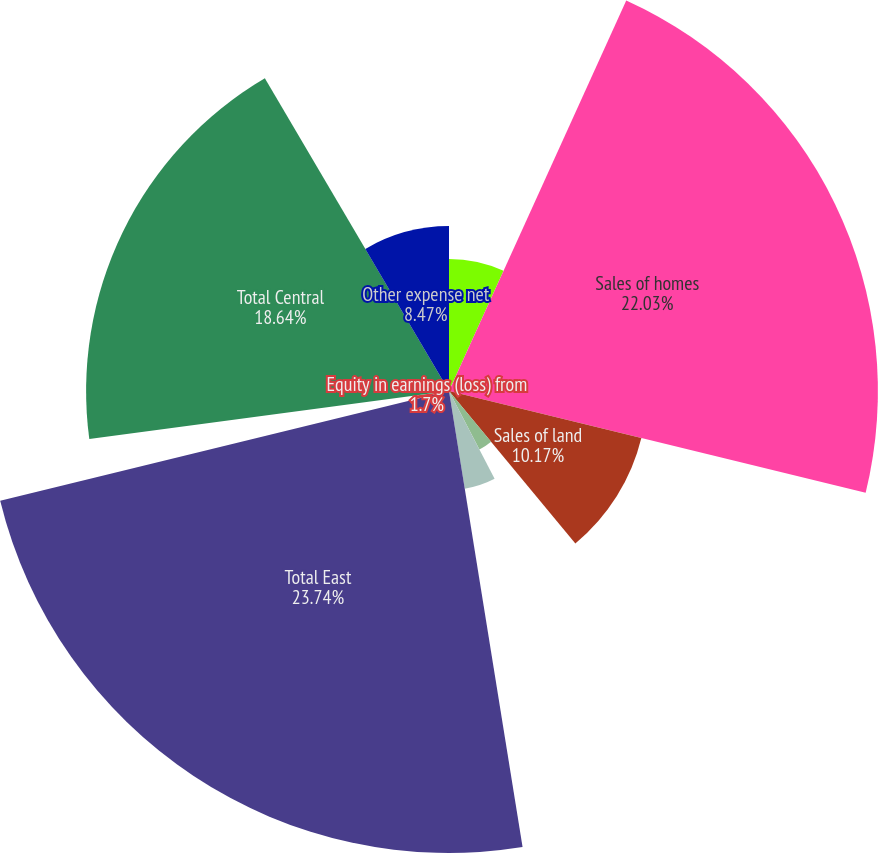Convert chart. <chart><loc_0><loc_0><loc_500><loc_500><pie_chart><fcel>(In thousands)<fcel>Sales of homes<fcel>Sales of land<fcel>Equity in loss from<fcel>Other income net<fcel>Total East<fcel>Equity in earnings (loss) from<fcel>Total Central<fcel>Equity in earnings from<fcel>Other expense net<nl><fcel>6.78%<fcel>22.03%<fcel>10.17%<fcel>3.39%<fcel>5.08%<fcel>23.73%<fcel>1.7%<fcel>18.64%<fcel>0.0%<fcel>8.47%<nl></chart> 